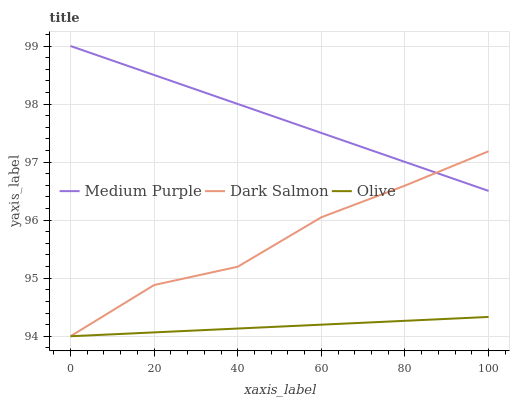Does Olive have the minimum area under the curve?
Answer yes or no. Yes. Does Medium Purple have the maximum area under the curve?
Answer yes or no. Yes. Does Dark Salmon have the minimum area under the curve?
Answer yes or no. No. Does Dark Salmon have the maximum area under the curve?
Answer yes or no. No. Is Medium Purple the smoothest?
Answer yes or no. Yes. Is Dark Salmon the roughest?
Answer yes or no. Yes. Is Olive the smoothest?
Answer yes or no. No. Is Olive the roughest?
Answer yes or no. No. Does Olive have the lowest value?
Answer yes or no. Yes. Does Medium Purple have the highest value?
Answer yes or no. Yes. Does Dark Salmon have the highest value?
Answer yes or no. No. Is Olive less than Medium Purple?
Answer yes or no. Yes. Is Medium Purple greater than Olive?
Answer yes or no. Yes. Does Medium Purple intersect Dark Salmon?
Answer yes or no. Yes. Is Medium Purple less than Dark Salmon?
Answer yes or no. No. Is Medium Purple greater than Dark Salmon?
Answer yes or no. No. Does Olive intersect Medium Purple?
Answer yes or no. No. 